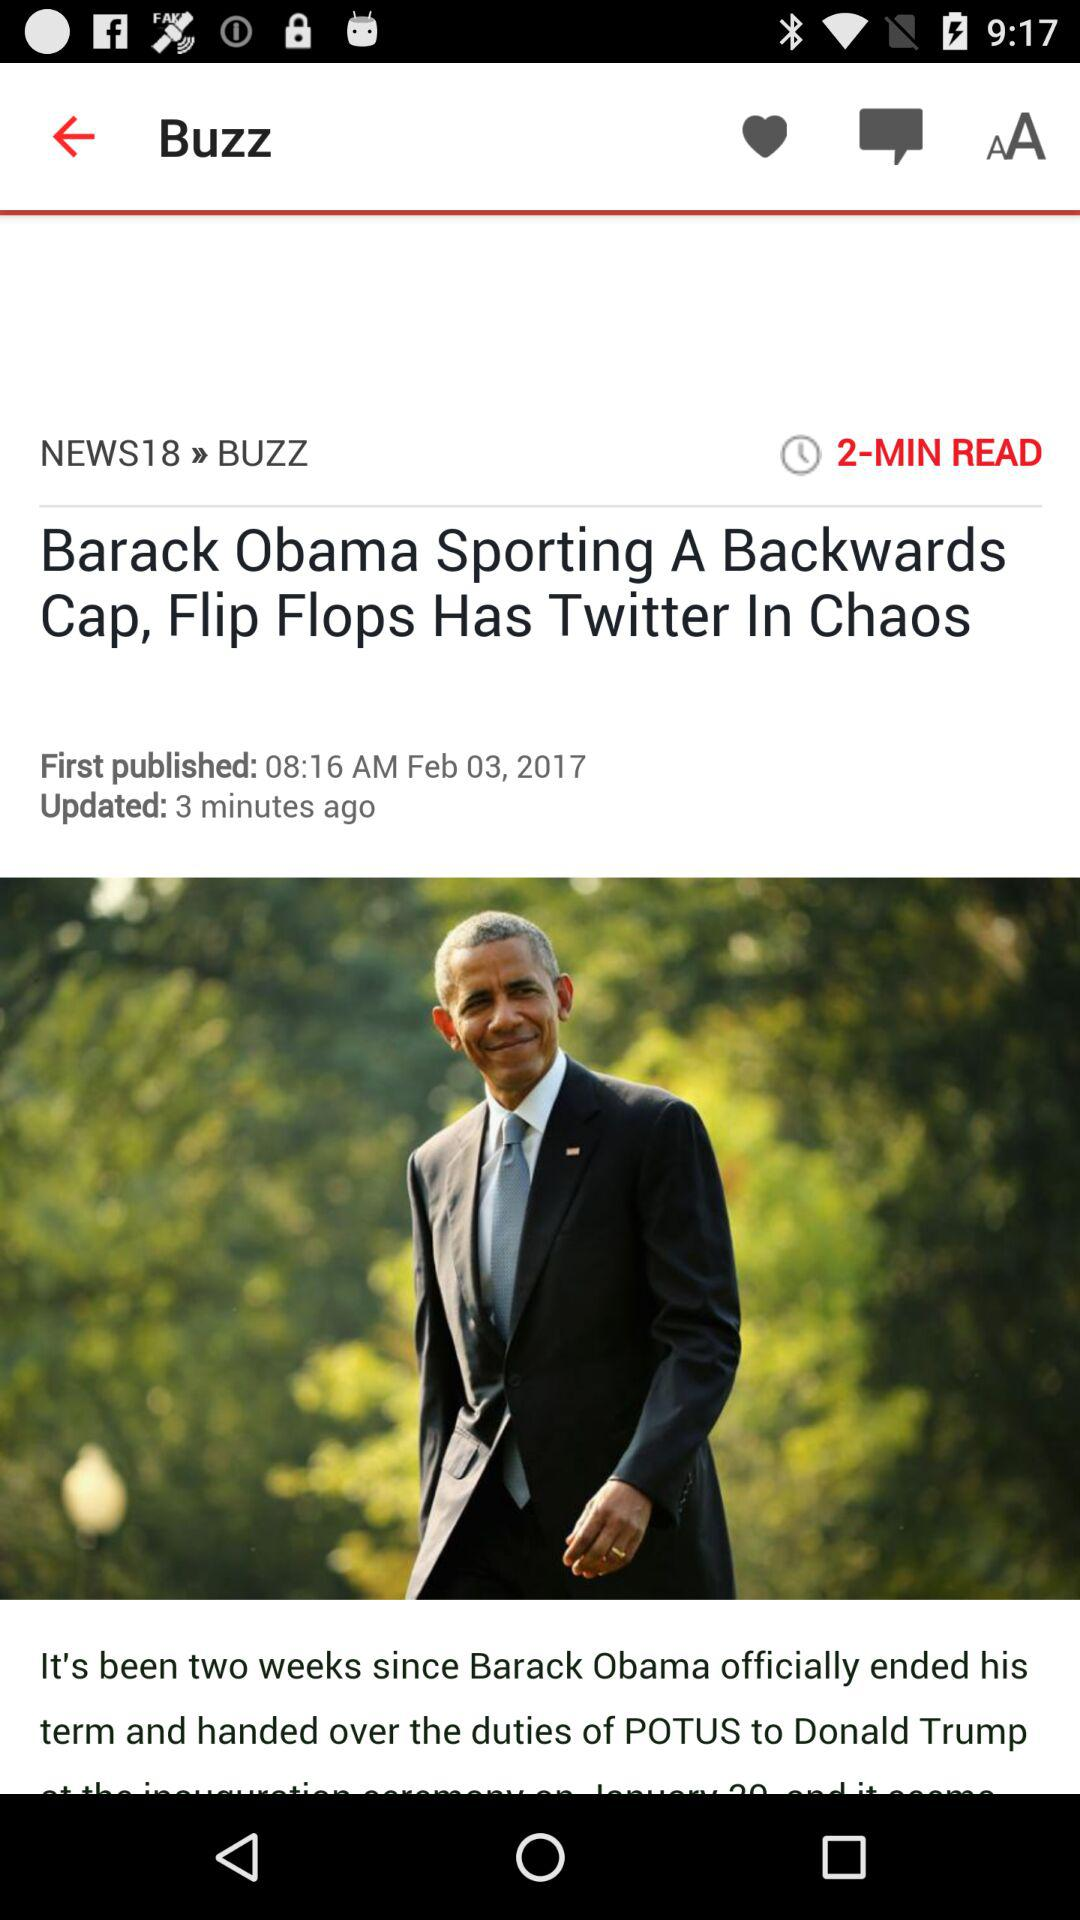When was the article updated? The article was updated 3 minutes ago. 